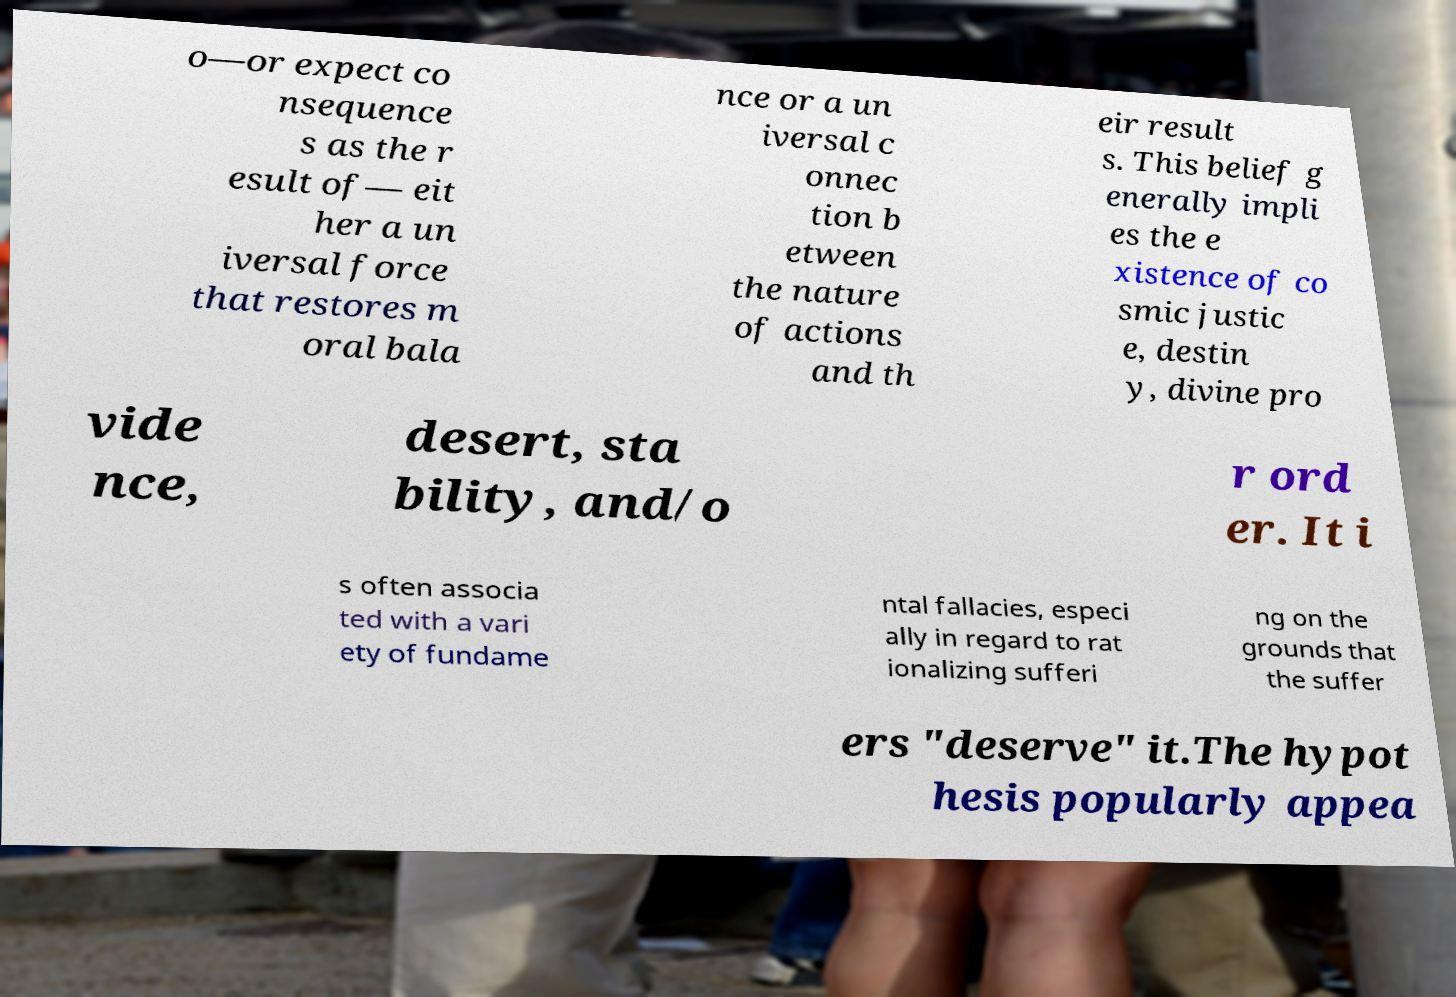Could you assist in decoding the text presented in this image and type it out clearly? o—or expect co nsequence s as the r esult of— eit her a un iversal force that restores m oral bala nce or a un iversal c onnec tion b etween the nature of actions and th eir result s. This belief g enerally impli es the e xistence of co smic justic e, destin y, divine pro vide nce, desert, sta bility, and/o r ord er. It i s often associa ted with a vari ety of fundame ntal fallacies, especi ally in regard to rat ionalizing sufferi ng on the grounds that the suffer ers "deserve" it.The hypot hesis popularly appea 